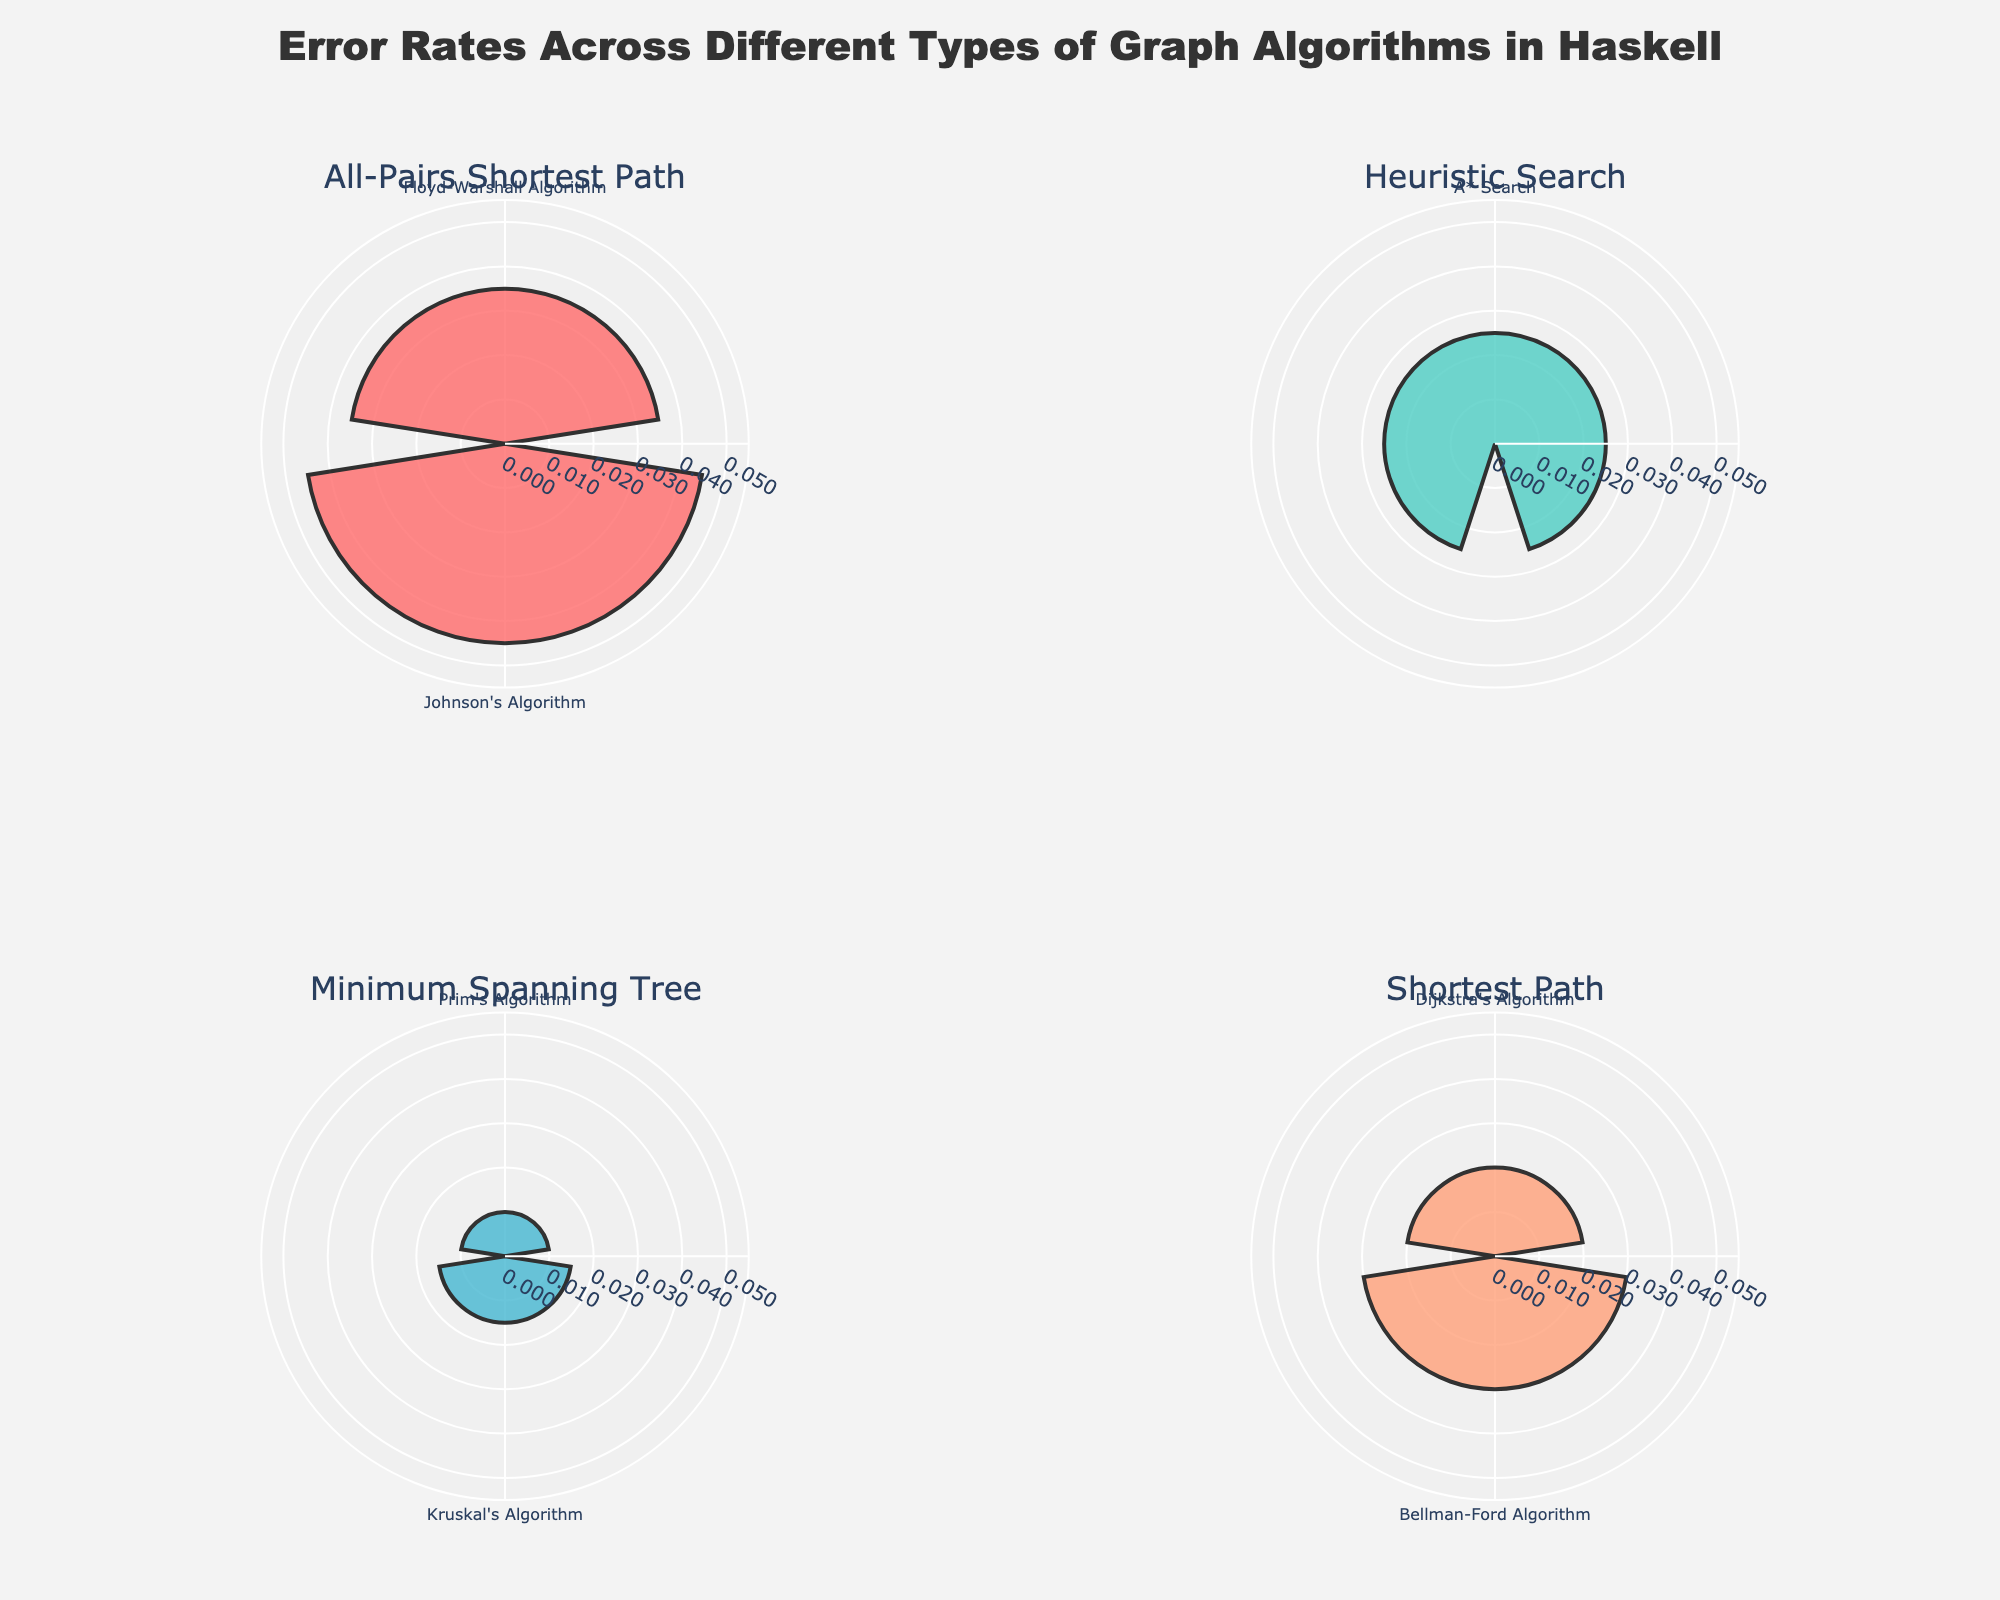What is the title of the plot? The title of the plot is displayed prominently at the top of the figure and reads "Error Rates Across Different Types of Graph Algorithms in Haskell".
Answer: Error Rates Across Different Types of Graph Algorithms in Haskell Which algorithm has the highest error rate? The algorithm with the highest error rate can be found by looking at the radial distance of the bars in each subplot. Kosaraju's Algorithm has the farthest radial distance, indicating the highest error rate.
Answer: Kosaraju's Algorithm How many types of graph algorithms are represented in the figure? The figure contains four subplots, each representing a different type of graph algorithm. These are shown by the subplot titles.
Answer: Four Compare the error rates of the A* Search and Floyd-Warshall Algorithm. Which one has a higher error rate? By observing the lengths of the bars in their respective subplots, Floyd-Warshall Algorithm has a longer bar indicating a higher error rate compared to A* Search.
Answer: Floyd-Warshall Algorithm What is the error rate of Prim's Algorithm? The error rate for Prim's Algorithm can be read directly from the length of its bar in the Minimum Spanning Tree subplot. The radial axis suggests it is 0.01.
Answer: 0.01 What is the average error rate for the algorithms in the All-Pairs Shortest Path category? The All-Pairs Shortest Path category includes Floyd-Warshall Algorithm (0.035) and Johnson's Algorithm (0.045). Adding them and dividing by 2 gives the average: (0.035 + 0.045) / 2 = 0.04.
Answer: 0.04 Which type of algorithm has the most algorithms represented in its subplot? By counting the bars in each subplot, the Strongly Connected Components type has the most algorithms represented, with two (Tarjan's and Kosaraju's).
Answer: Strongly Connected Components Compare the error rates of Dijkstra's Algorithm and Bellman-Ford Algorithm. Which one has a lower error rate and by how much? Dijkstra's Algorithm has an error rate of 0.02, and Bellman-Ford Algorithm has an error rate of 0.03. The difference is 0.03 - 0.02 = 0.01. Therefore, Dijkstra's Algorithm has a lower error rate by 0.01.
Answer: Dijkstra's Algorithm by 0.01 What is the combined error rate of the Strongly Connected Components algorithms? The error rates for Strongly Connected Components are for Tarjan's Algorithm (0.04) and Kosaraju's Algorithm (0.05). Summing these, the combined error rate is 0.04 + 0.05 = 0.09.
Answer: 0.09 